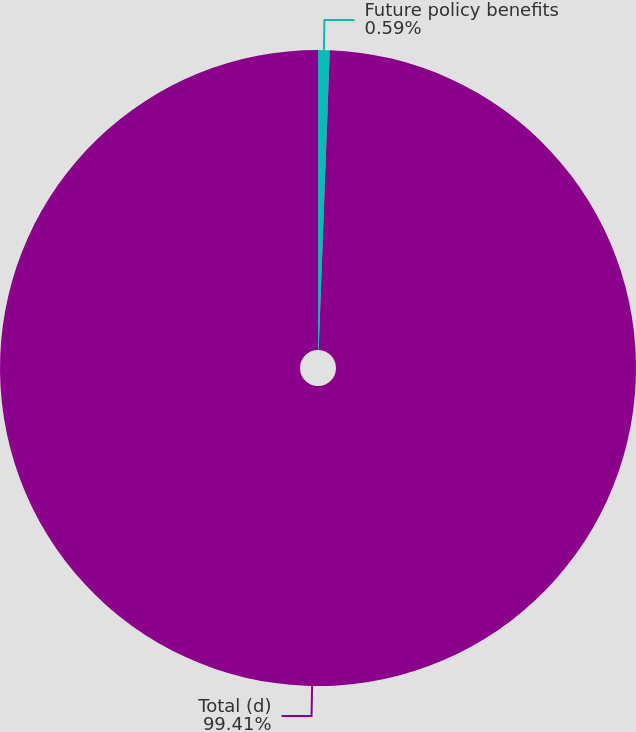<chart> <loc_0><loc_0><loc_500><loc_500><pie_chart><fcel>Future policy benefits<fcel>Total (d)<nl><fcel>0.59%<fcel>99.41%<nl></chart> 